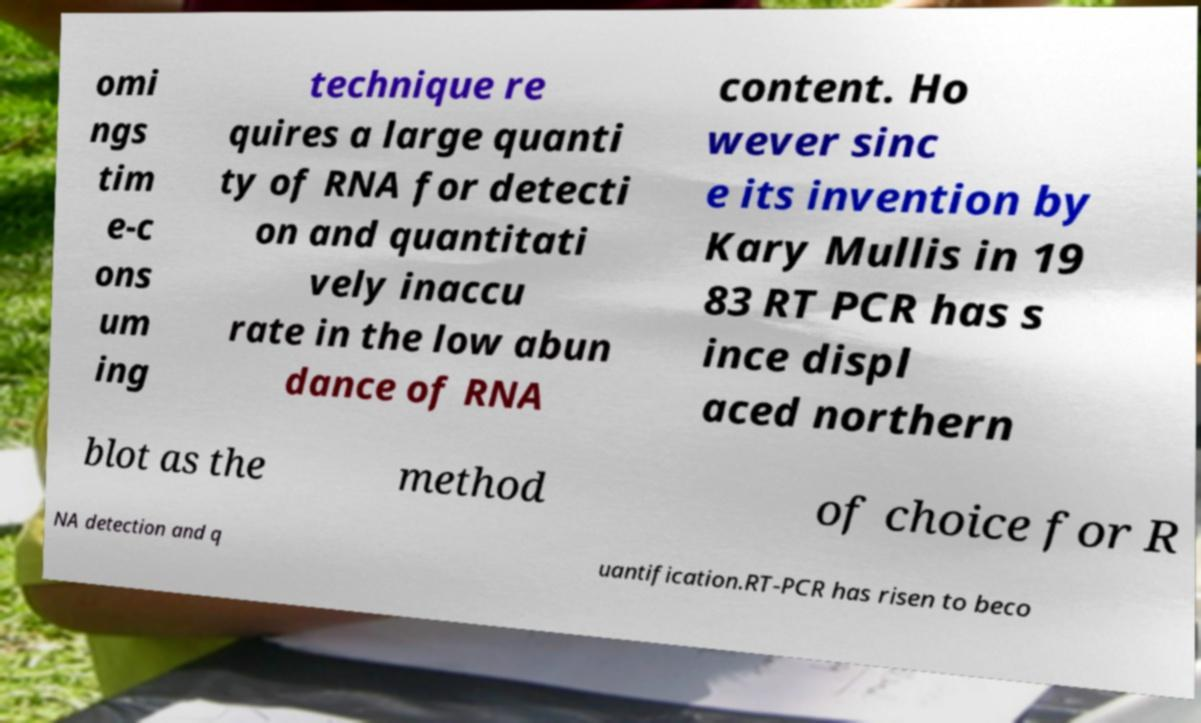Could you extract and type out the text from this image? omi ngs tim e-c ons um ing technique re quires a large quanti ty of RNA for detecti on and quantitati vely inaccu rate in the low abun dance of RNA content. Ho wever sinc e its invention by Kary Mullis in 19 83 RT PCR has s ince displ aced northern blot as the method of choice for R NA detection and q uantification.RT-PCR has risen to beco 